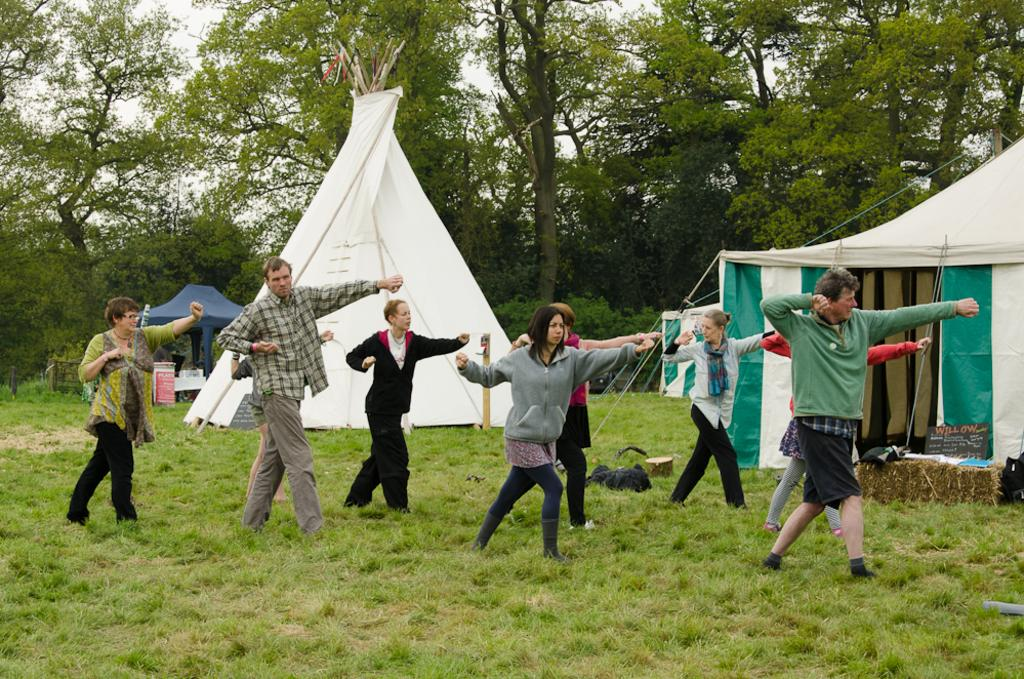What is the surface on which the people are standing in the image? The people are standing on the grass in the image. What type of temporary shelters can be seen in the image? There are tents visible in the image. What might the people need for their belongings? Baggage is present in the image, which suggests the people might be carrying their belongings. What type of natural vegetation is visible in the image? Trees are visible in the image. Where is the jail located in the image? There is no jail present in the image. How many snakes can be seen slithering on the grass in the image? There are no snakes visible in the image; it features people on the grass, tents, baggage, and trees. 